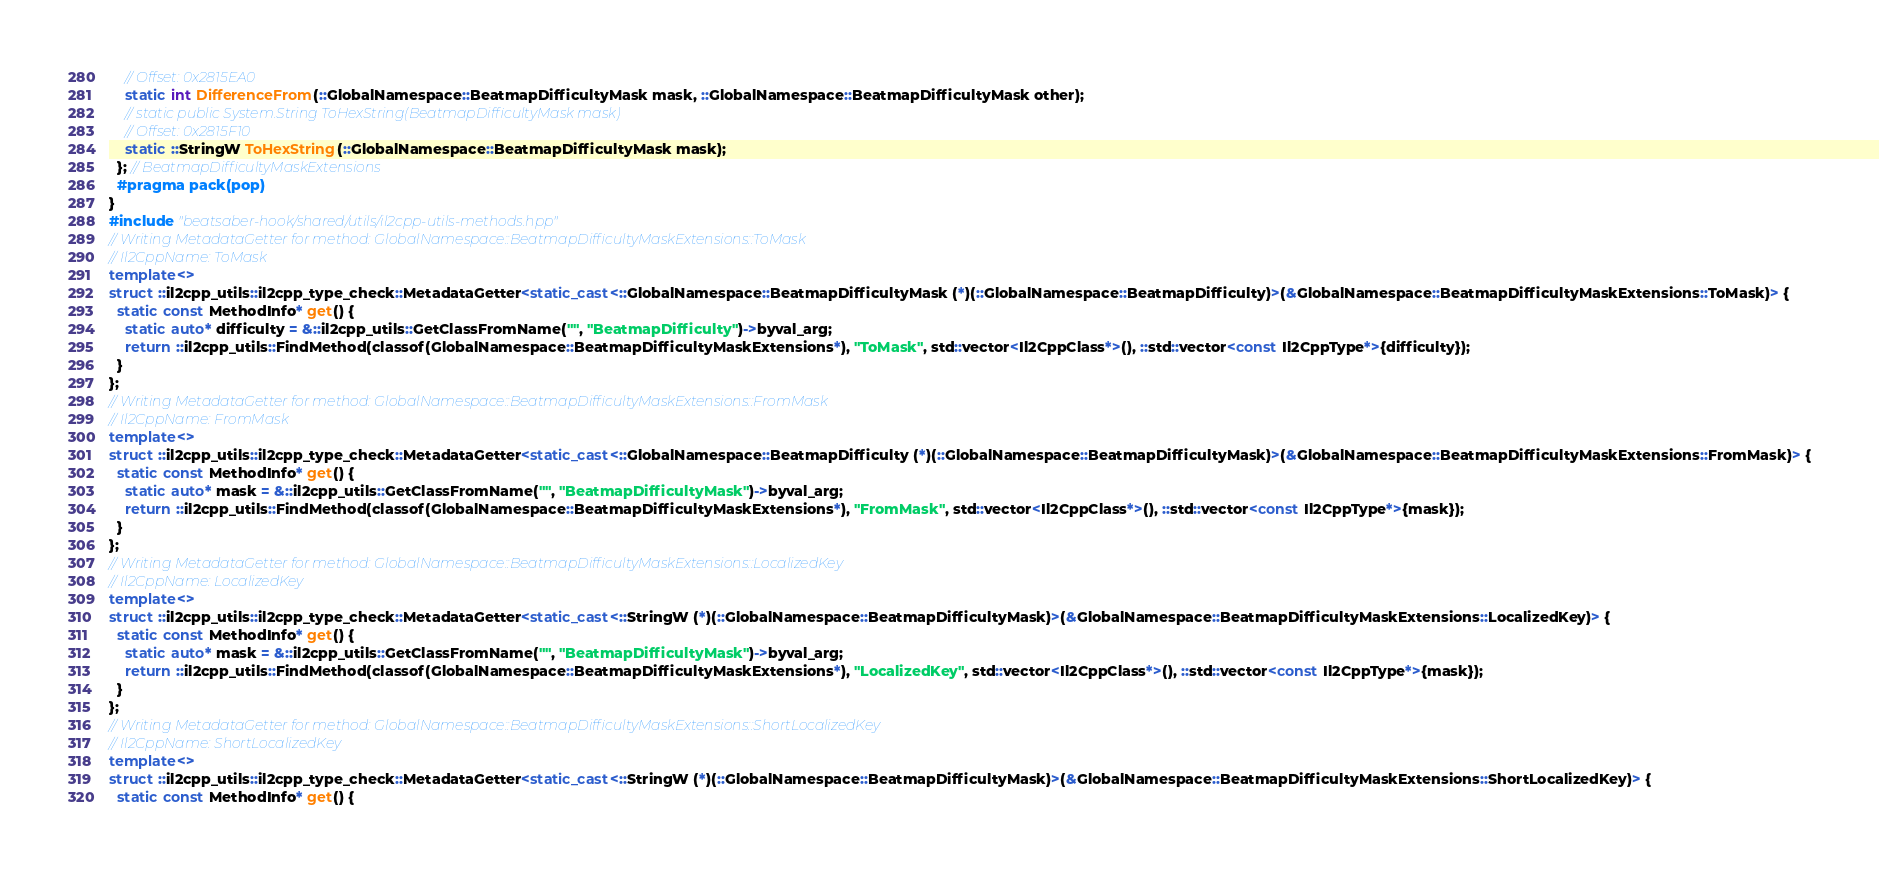Convert code to text. <code><loc_0><loc_0><loc_500><loc_500><_C++_>    // Offset: 0x2815EA0
    static int DifferenceFrom(::GlobalNamespace::BeatmapDifficultyMask mask, ::GlobalNamespace::BeatmapDifficultyMask other);
    // static public System.String ToHexString(BeatmapDifficultyMask mask)
    // Offset: 0x2815F10
    static ::StringW ToHexString(::GlobalNamespace::BeatmapDifficultyMask mask);
  }; // BeatmapDifficultyMaskExtensions
  #pragma pack(pop)
}
#include "beatsaber-hook/shared/utils/il2cpp-utils-methods.hpp"
// Writing MetadataGetter for method: GlobalNamespace::BeatmapDifficultyMaskExtensions::ToMask
// Il2CppName: ToMask
template<>
struct ::il2cpp_utils::il2cpp_type_check::MetadataGetter<static_cast<::GlobalNamespace::BeatmapDifficultyMask (*)(::GlobalNamespace::BeatmapDifficulty)>(&GlobalNamespace::BeatmapDifficultyMaskExtensions::ToMask)> {
  static const MethodInfo* get() {
    static auto* difficulty = &::il2cpp_utils::GetClassFromName("", "BeatmapDifficulty")->byval_arg;
    return ::il2cpp_utils::FindMethod(classof(GlobalNamespace::BeatmapDifficultyMaskExtensions*), "ToMask", std::vector<Il2CppClass*>(), ::std::vector<const Il2CppType*>{difficulty});
  }
};
// Writing MetadataGetter for method: GlobalNamespace::BeatmapDifficultyMaskExtensions::FromMask
// Il2CppName: FromMask
template<>
struct ::il2cpp_utils::il2cpp_type_check::MetadataGetter<static_cast<::GlobalNamespace::BeatmapDifficulty (*)(::GlobalNamespace::BeatmapDifficultyMask)>(&GlobalNamespace::BeatmapDifficultyMaskExtensions::FromMask)> {
  static const MethodInfo* get() {
    static auto* mask = &::il2cpp_utils::GetClassFromName("", "BeatmapDifficultyMask")->byval_arg;
    return ::il2cpp_utils::FindMethod(classof(GlobalNamespace::BeatmapDifficultyMaskExtensions*), "FromMask", std::vector<Il2CppClass*>(), ::std::vector<const Il2CppType*>{mask});
  }
};
// Writing MetadataGetter for method: GlobalNamespace::BeatmapDifficultyMaskExtensions::LocalizedKey
// Il2CppName: LocalizedKey
template<>
struct ::il2cpp_utils::il2cpp_type_check::MetadataGetter<static_cast<::StringW (*)(::GlobalNamespace::BeatmapDifficultyMask)>(&GlobalNamespace::BeatmapDifficultyMaskExtensions::LocalizedKey)> {
  static const MethodInfo* get() {
    static auto* mask = &::il2cpp_utils::GetClassFromName("", "BeatmapDifficultyMask")->byval_arg;
    return ::il2cpp_utils::FindMethod(classof(GlobalNamespace::BeatmapDifficultyMaskExtensions*), "LocalizedKey", std::vector<Il2CppClass*>(), ::std::vector<const Il2CppType*>{mask});
  }
};
// Writing MetadataGetter for method: GlobalNamespace::BeatmapDifficultyMaskExtensions::ShortLocalizedKey
// Il2CppName: ShortLocalizedKey
template<>
struct ::il2cpp_utils::il2cpp_type_check::MetadataGetter<static_cast<::StringW (*)(::GlobalNamespace::BeatmapDifficultyMask)>(&GlobalNamespace::BeatmapDifficultyMaskExtensions::ShortLocalizedKey)> {
  static const MethodInfo* get() {</code> 